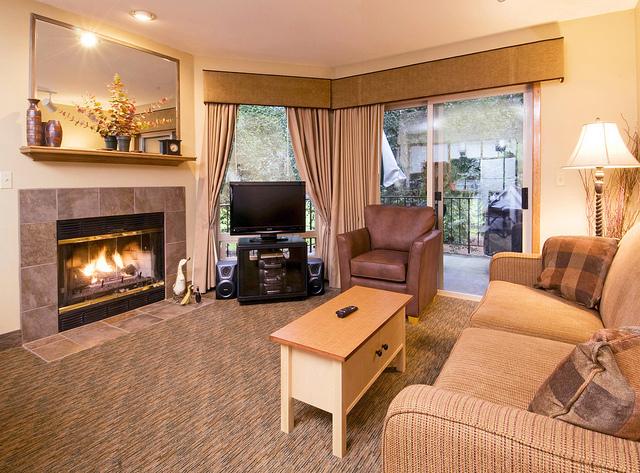What is the flooring?
Write a very short answer. Carpet. What shape is the coffee table?
Short answer required. Rectangle. What color is the valance?
Give a very brief answer. Brown. Is there a fire in the fireplace?
Be succinct. Yes. 